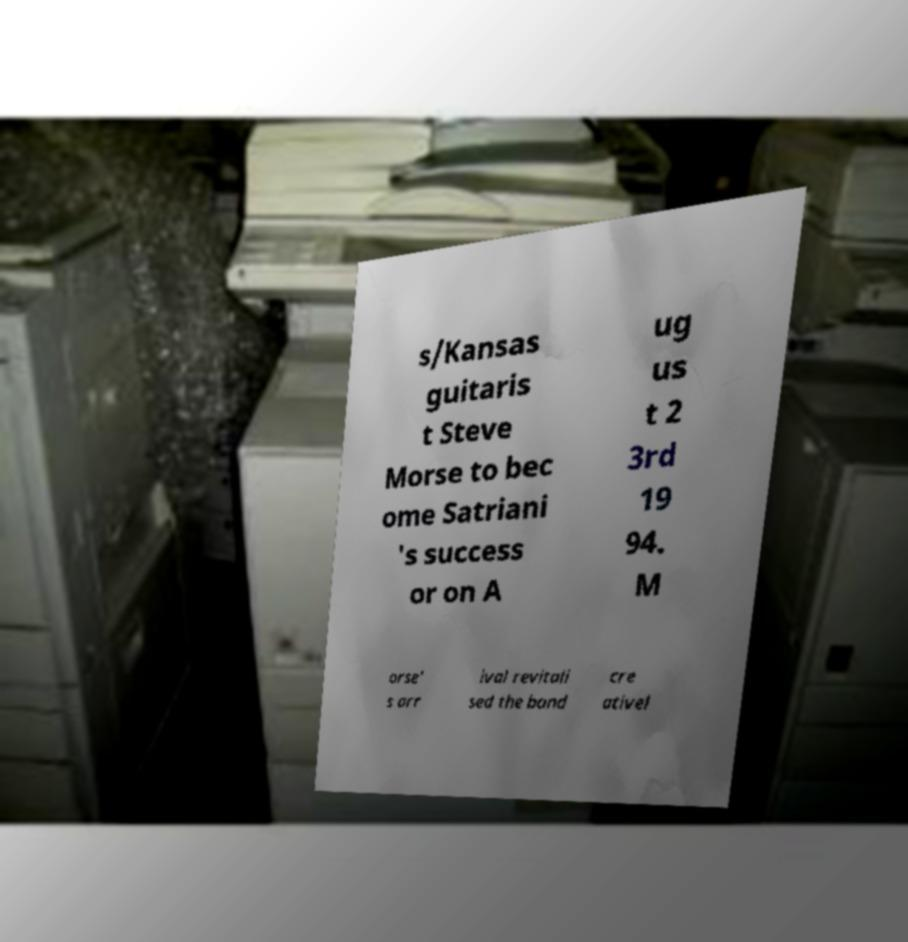Can you read and provide the text displayed in the image?This photo seems to have some interesting text. Can you extract and type it out for me? s/Kansas guitaris t Steve Morse to bec ome Satriani 's success or on A ug us t 2 3rd 19 94. M orse' s arr ival revitali sed the band cre ativel 